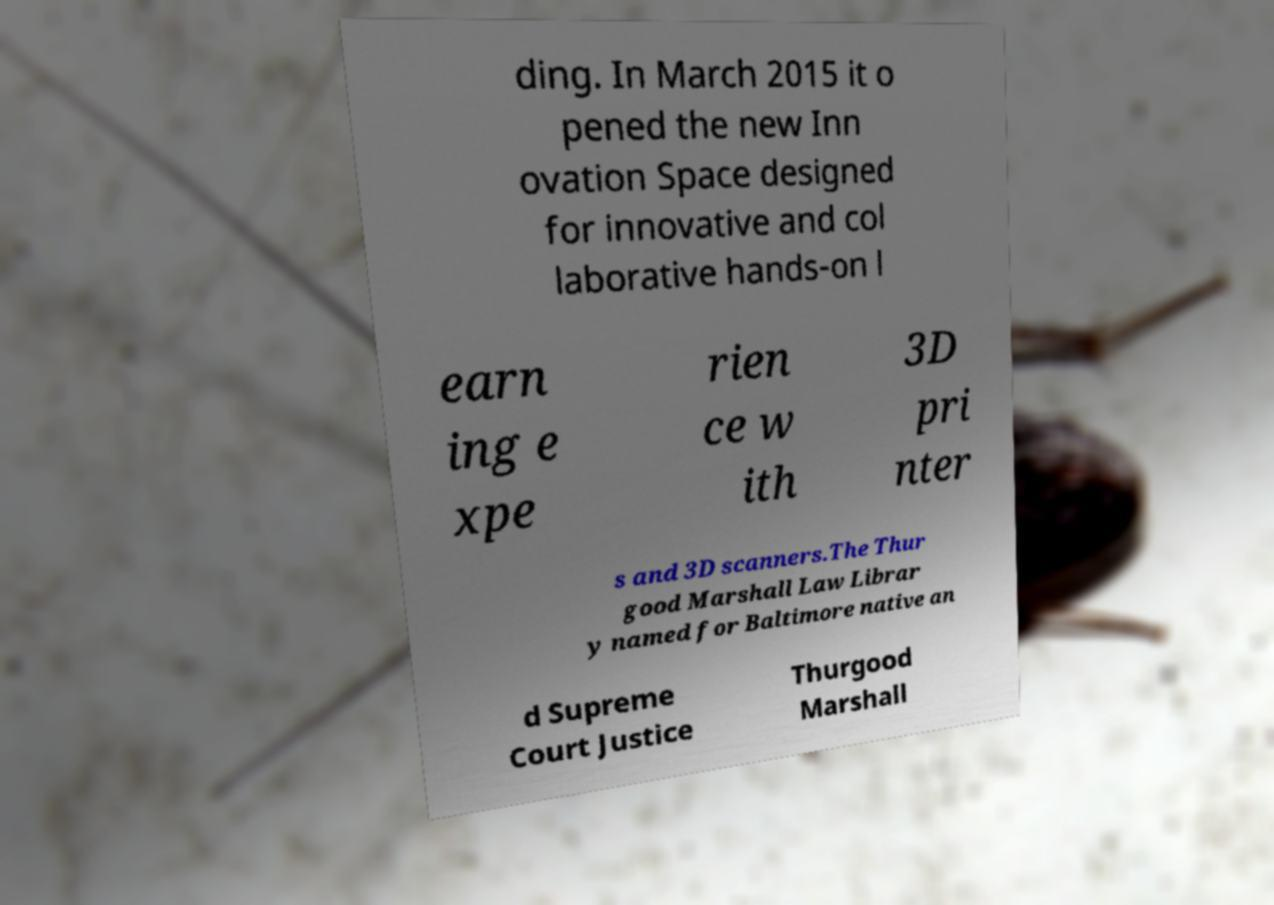For documentation purposes, I need the text within this image transcribed. Could you provide that? ding. In March 2015 it o pened the new Inn ovation Space designed for innovative and col laborative hands-on l earn ing e xpe rien ce w ith 3D pri nter s and 3D scanners.The Thur good Marshall Law Librar y named for Baltimore native an d Supreme Court Justice Thurgood Marshall 